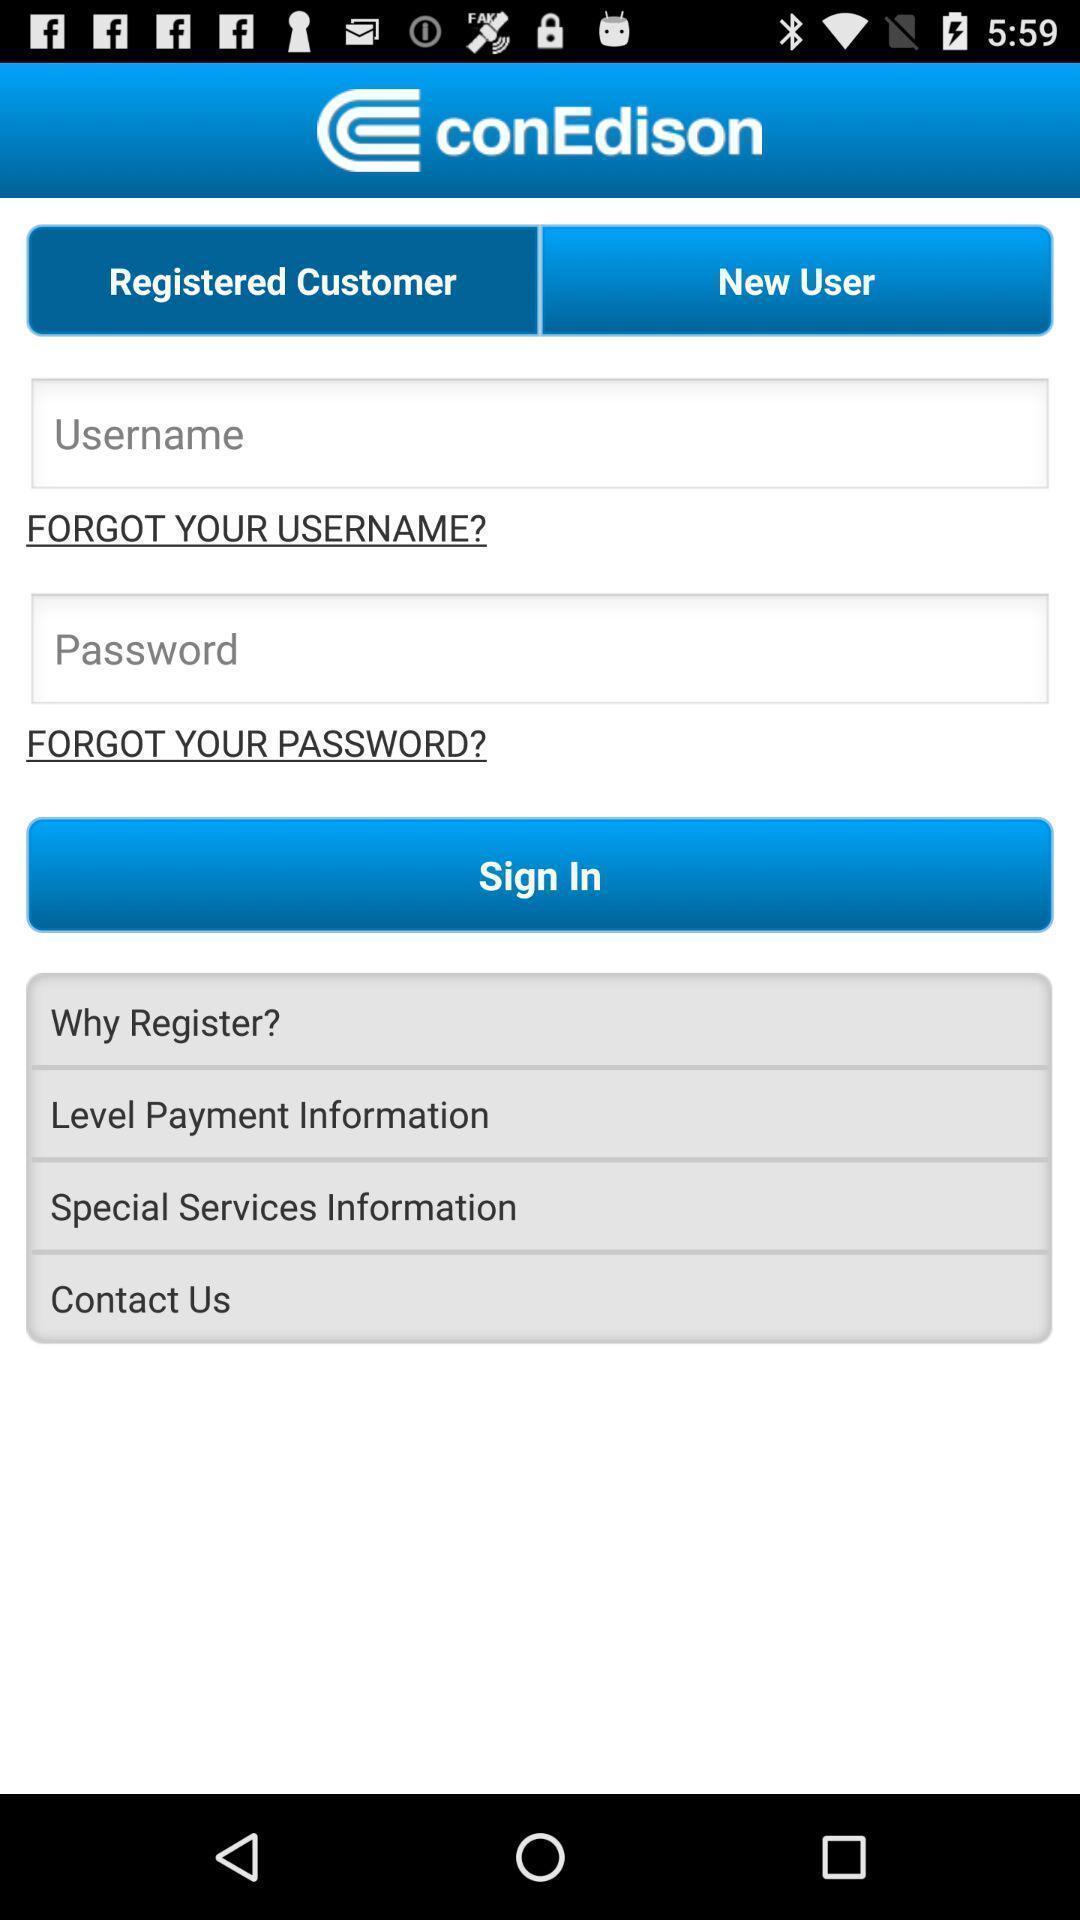Describe the key features of this screenshot. Sign-in page is displaying. 